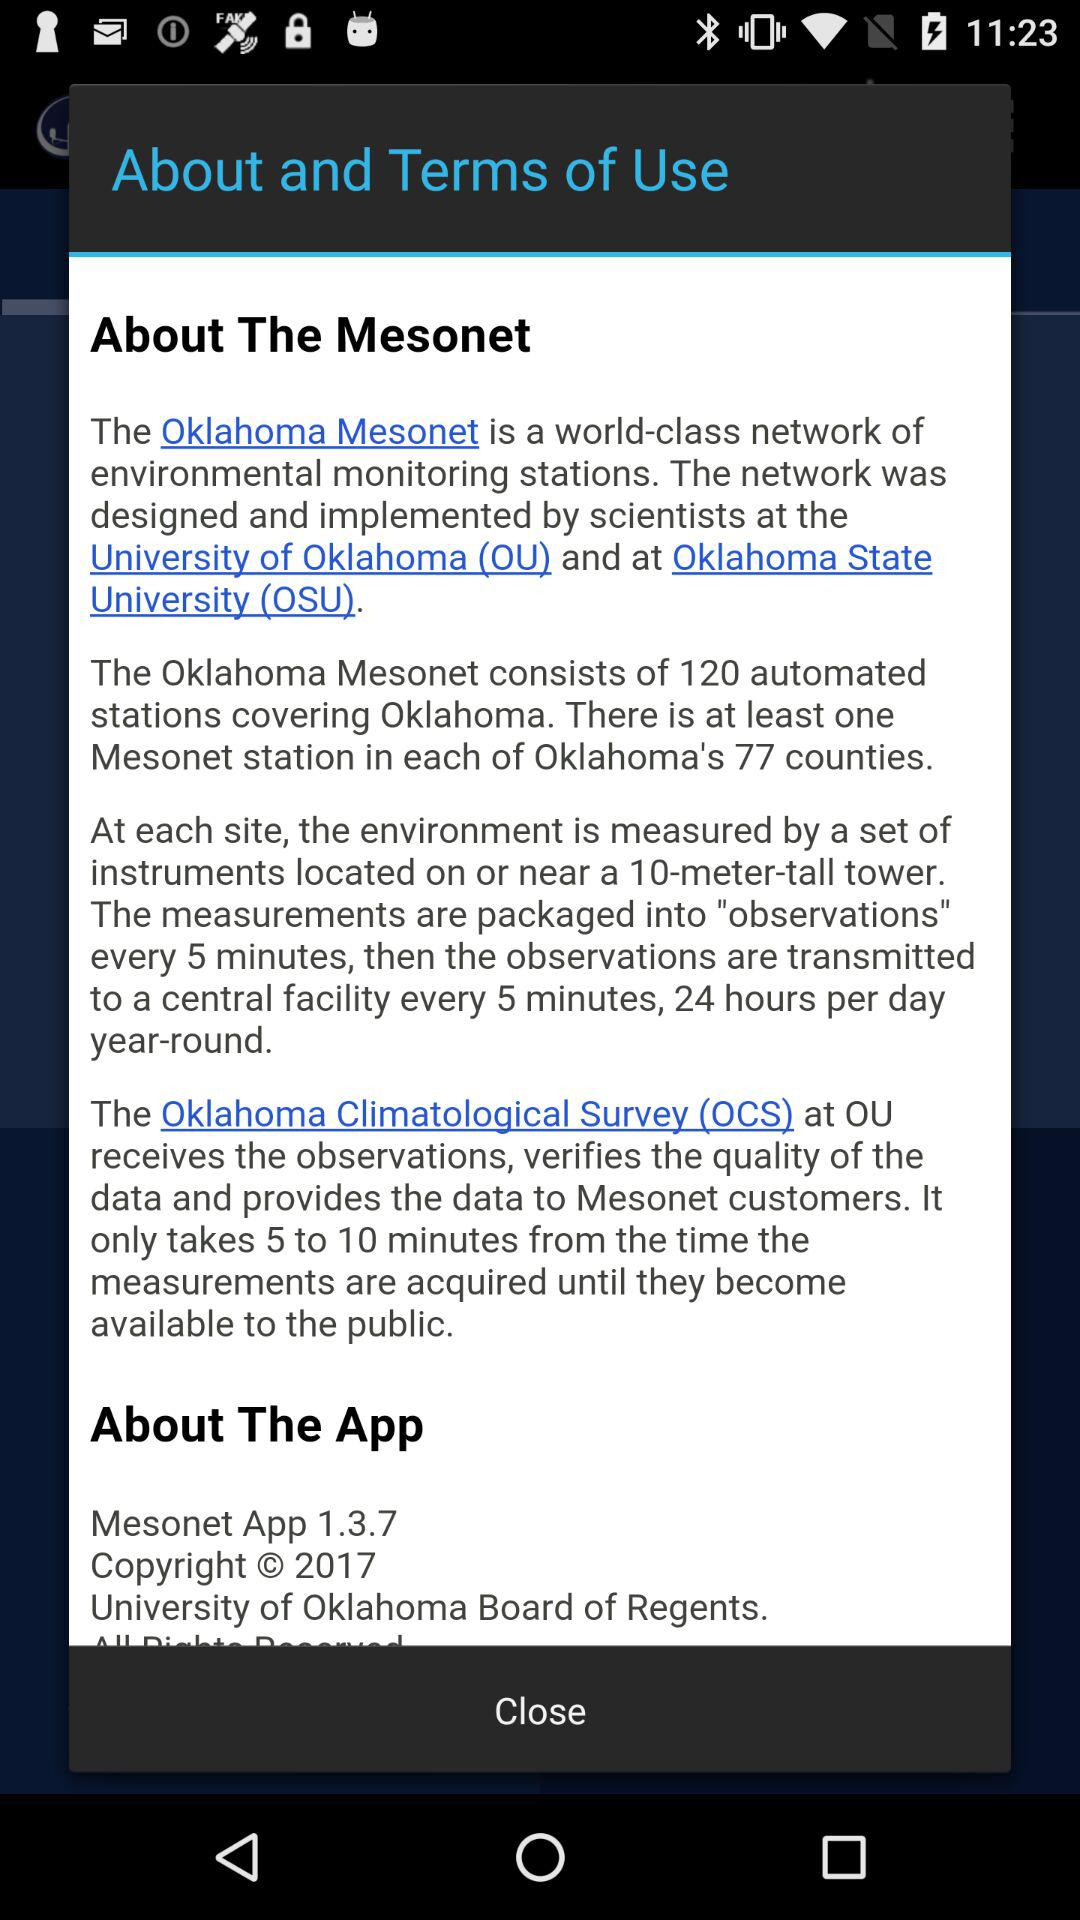How many stations does Oklahoma Mesonet consist of? There are 120 stations that Oklahoma Mesonet consists of. 